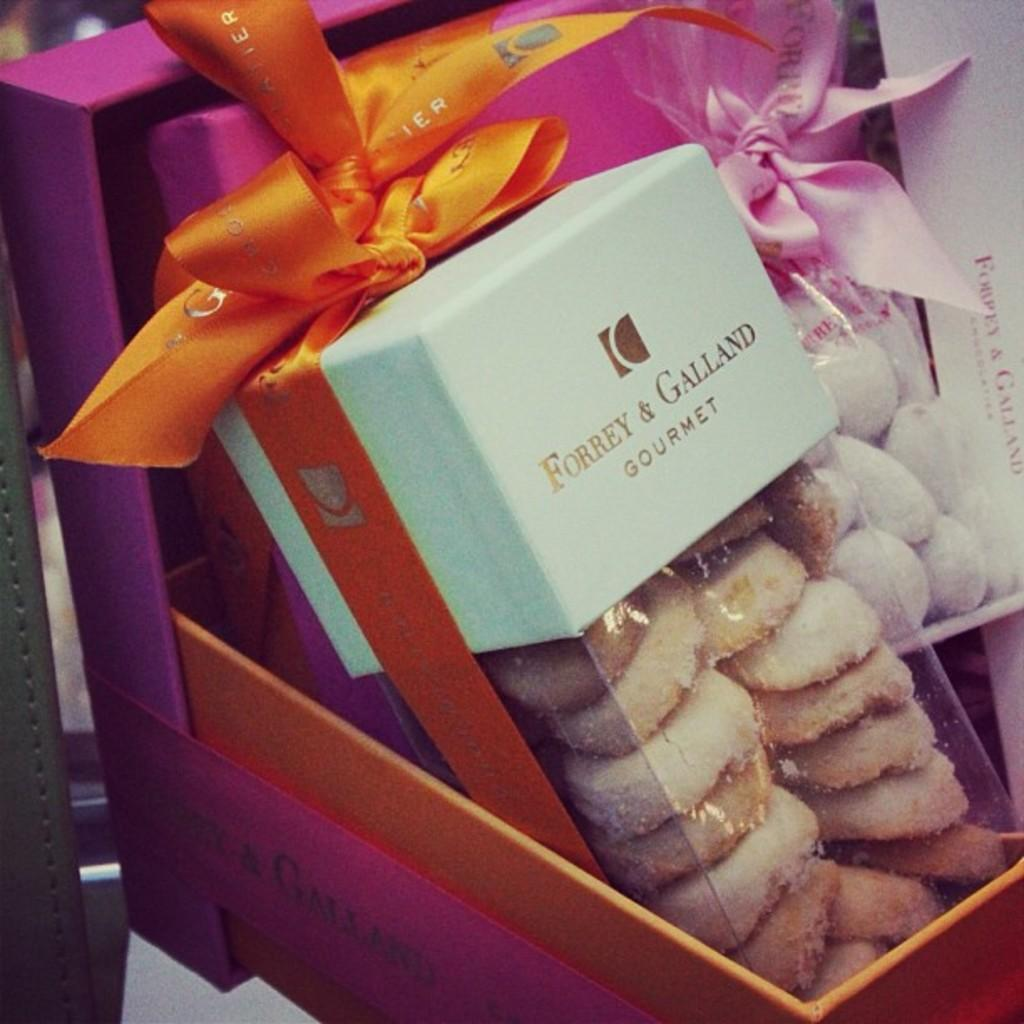What type of food can be seen in the image? There are cookies in the image. How are the cookies stored or contained? The cookies are in a box. What color is the box? The box is purple. How many ribbons are present in the image? There are two ribbons in the image. What colors are the ribbons? One ribbon is orange, and the other ribbon is pink. What type of office equipment can be seen in the image? There is no office equipment present in the image; it features cookies in a purple box with ribbons. 